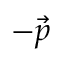Convert formula to latex. <formula><loc_0><loc_0><loc_500><loc_500>- \vec { p }</formula> 